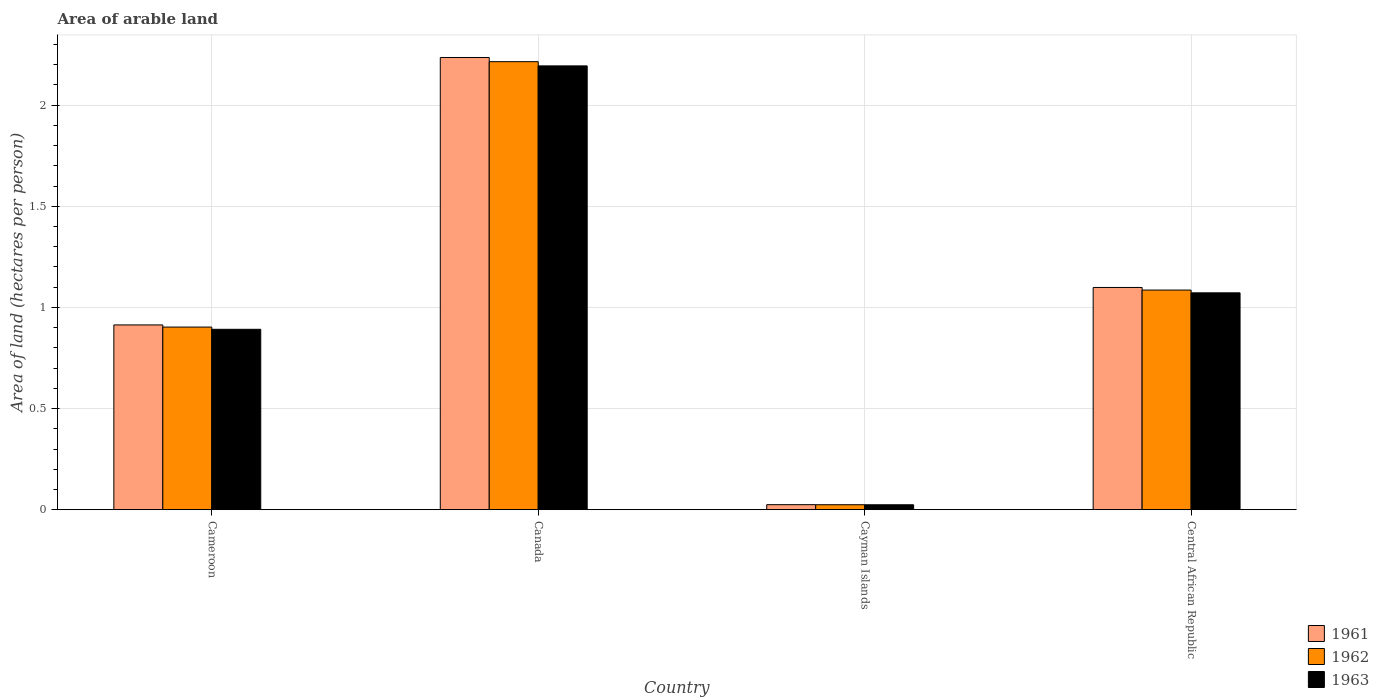How many different coloured bars are there?
Make the answer very short. 3. How many groups of bars are there?
Give a very brief answer. 4. Are the number of bars per tick equal to the number of legend labels?
Make the answer very short. Yes. How many bars are there on the 2nd tick from the left?
Your answer should be compact. 3. What is the label of the 4th group of bars from the left?
Make the answer very short. Central African Republic. What is the total arable land in 1962 in Central African Republic?
Your response must be concise. 1.09. Across all countries, what is the maximum total arable land in 1961?
Make the answer very short. 2.24. Across all countries, what is the minimum total arable land in 1963?
Offer a very short reply. 0.02. In which country was the total arable land in 1962 minimum?
Provide a succinct answer. Cayman Islands. What is the total total arable land in 1962 in the graph?
Keep it short and to the point. 4.23. What is the difference between the total arable land in 1962 in Cameroon and that in Cayman Islands?
Make the answer very short. 0.88. What is the difference between the total arable land in 1963 in Cayman Islands and the total arable land in 1961 in Central African Republic?
Provide a short and direct response. -1.07. What is the average total arable land in 1961 per country?
Offer a very short reply. 1.07. What is the difference between the total arable land of/in 1961 and total arable land of/in 1962 in Cayman Islands?
Keep it short and to the point. 0. In how many countries, is the total arable land in 1961 greater than 1.2 hectares per person?
Provide a succinct answer. 1. What is the ratio of the total arable land in 1963 in Cameroon to that in Cayman Islands?
Offer a terse response. 36.69. Is the difference between the total arable land in 1961 in Canada and Central African Republic greater than the difference between the total arable land in 1962 in Canada and Central African Republic?
Your answer should be very brief. Yes. What is the difference between the highest and the second highest total arable land in 1961?
Keep it short and to the point. -0.19. What is the difference between the highest and the lowest total arable land in 1961?
Your response must be concise. 2.21. In how many countries, is the total arable land in 1962 greater than the average total arable land in 1962 taken over all countries?
Your response must be concise. 2. Is the sum of the total arable land in 1961 in Cayman Islands and Central African Republic greater than the maximum total arable land in 1962 across all countries?
Your answer should be very brief. No. How many bars are there?
Ensure brevity in your answer.  12. Are all the bars in the graph horizontal?
Your response must be concise. No. How many countries are there in the graph?
Your answer should be very brief. 4. What is the difference between two consecutive major ticks on the Y-axis?
Your answer should be compact. 0.5. Does the graph contain any zero values?
Your answer should be very brief. No. Does the graph contain grids?
Give a very brief answer. Yes. How many legend labels are there?
Provide a succinct answer. 3. What is the title of the graph?
Keep it short and to the point. Area of arable land. Does "2004" appear as one of the legend labels in the graph?
Your response must be concise. No. What is the label or title of the Y-axis?
Your response must be concise. Area of land (hectares per person). What is the Area of land (hectares per person) of 1961 in Cameroon?
Your response must be concise. 0.91. What is the Area of land (hectares per person) of 1962 in Cameroon?
Make the answer very short. 0.9. What is the Area of land (hectares per person) of 1963 in Cameroon?
Your answer should be compact. 0.89. What is the Area of land (hectares per person) of 1961 in Canada?
Provide a succinct answer. 2.24. What is the Area of land (hectares per person) in 1962 in Canada?
Provide a short and direct response. 2.21. What is the Area of land (hectares per person) in 1963 in Canada?
Offer a very short reply. 2.19. What is the Area of land (hectares per person) in 1961 in Cayman Islands?
Keep it short and to the point. 0.02. What is the Area of land (hectares per person) of 1962 in Cayman Islands?
Your response must be concise. 0.02. What is the Area of land (hectares per person) in 1963 in Cayman Islands?
Your answer should be compact. 0.02. What is the Area of land (hectares per person) of 1961 in Central African Republic?
Ensure brevity in your answer.  1.1. What is the Area of land (hectares per person) in 1962 in Central African Republic?
Your answer should be very brief. 1.09. What is the Area of land (hectares per person) in 1963 in Central African Republic?
Make the answer very short. 1.07. Across all countries, what is the maximum Area of land (hectares per person) of 1961?
Your response must be concise. 2.24. Across all countries, what is the maximum Area of land (hectares per person) in 1962?
Your answer should be compact. 2.21. Across all countries, what is the maximum Area of land (hectares per person) of 1963?
Ensure brevity in your answer.  2.19. Across all countries, what is the minimum Area of land (hectares per person) in 1961?
Give a very brief answer. 0.02. Across all countries, what is the minimum Area of land (hectares per person) of 1962?
Your answer should be very brief. 0.02. Across all countries, what is the minimum Area of land (hectares per person) of 1963?
Provide a succinct answer. 0.02. What is the total Area of land (hectares per person) in 1961 in the graph?
Your answer should be compact. 4.27. What is the total Area of land (hectares per person) in 1962 in the graph?
Keep it short and to the point. 4.23. What is the total Area of land (hectares per person) of 1963 in the graph?
Offer a very short reply. 4.18. What is the difference between the Area of land (hectares per person) in 1961 in Cameroon and that in Canada?
Make the answer very short. -1.32. What is the difference between the Area of land (hectares per person) in 1962 in Cameroon and that in Canada?
Keep it short and to the point. -1.31. What is the difference between the Area of land (hectares per person) of 1963 in Cameroon and that in Canada?
Your answer should be very brief. -1.3. What is the difference between the Area of land (hectares per person) of 1961 in Cameroon and that in Cayman Islands?
Make the answer very short. 0.89. What is the difference between the Area of land (hectares per person) in 1962 in Cameroon and that in Cayman Islands?
Provide a short and direct response. 0.88. What is the difference between the Area of land (hectares per person) in 1963 in Cameroon and that in Cayman Islands?
Make the answer very short. 0.87. What is the difference between the Area of land (hectares per person) of 1961 in Cameroon and that in Central African Republic?
Ensure brevity in your answer.  -0.19. What is the difference between the Area of land (hectares per person) of 1962 in Cameroon and that in Central African Republic?
Make the answer very short. -0.18. What is the difference between the Area of land (hectares per person) of 1963 in Cameroon and that in Central African Republic?
Your response must be concise. -0.18. What is the difference between the Area of land (hectares per person) of 1961 in Canada and that in Cayman Islands?
Provide a succinct answer. 2.21. What is the difference between the Area of land (hectares per person) in 1962 in Canada and that in Cayman Islands?
Your answer should be compact. 2.19. What is the difference between the Area of land (hectares per person) in 1963 in Canada and that in Cayman Islands?
Offer a terse response. 2.17. What is the difference between the Area of land (hectares per person) in 1961 in Canada and that in Central African Republic?
Offer a very short reply. 1.14. What is the difference between the Area of land (hectares per person) in 1962 in Canada and that in Central African Republic?
Make the answer very short. 1.13. What is the difference between the Area of land (hectares per person) of 1963 in Canada and that in Central African Republic?
Provide a succinct answer. 1.12. What is the difference between the Area of land (hectares per person) of 1961 in Cayman Islands and that in Central African Republic?
Your response must be concise. -1.07. What is the difference between the Area of land (hectares per person) of 1962 in Cayman Islands and that in Central African Republic?
Make the answer very short. -1.06. What is the difference between the Area of land (hectares per person) of 1963 in Cayman Islands and that in Central African Republic?
Make the answer very short. -1.05. What is the difference between the Area of land (hectares per person) in 1961 in Cameroon and the Area of land (hectares per person) in 1962 in Canada?
Your answer should be compact. -1.3. What is the difference between the Area of land (hectares per person) in 1961 in Cameroon and the Area of land (hectares per person) in 1963 in Canada?
Ensure brevity in your answer.  -1.28. What is the difference between the Area of land (hectares per person) of 1962 in Cameroon and the Area of land (hectares per person) of 1963 in Canada?
Keep it short and to the point. -1.29. What is the difference between the Area of land (hectares per person) in 1961 in Cameroon and the Area of land (hectares per person) in 1962 in Cayman Islands?
Ensure brevity in your answer.  0.89. What is the difference between the Area of land (hectares per person) of 1961 in Cameroon and the Area of land (hectares per person) of 1963 in Cayman Islands?
Offer a very short reply. 0.89. What is the difference between the Area of land (hectares per person) in 1962 in Cameroon and the Area of land (hectares per person) in 1963 in Cayman Islands?
Make the answer very short. 0.88. What is the difference between the Area of land (hectares per person) of 1961 in Cameroon and the Area of land (hectares per person) of 1962 in Central African Republic?
Make the answer very short. -0.17. What is the difference between the Area of land (hectares per person) in 1961 in Cameroon and the Area of land (hectares per person) in 1963 in Central African Republic?
Make the answer very short. -0.16. What is the difference between the Area of land (hectares per person) in 1962 in Cameroon and the Area of land (hectares per person) in 1963 in Central African Republic?
Ensure brevity in your answer.  -0.17. What is the difference between the Area of land (hectares per person) in 1961 in Canada and the Area of land (hectares per person) in 1962 in Cayman Islands?
Provide a short and direct response. 2.21. What is the difference between the Area of land (hectares per person) of 1961 in Canada and the Area of land (hectares per person) of 1963 in Cayman Islands?
Your response must be concise. 2.21. What is the difference between the Area of land (hectares per person) in 1962 in Canada and the Area of land (hectares per person) in 1963 in Cayman Islands?
Give a very brief answer. 2.19. What is the difference between the Area of land (hectares per person) in 1961 in Canada and the Area of land (hectares per person) in 1962 in Central African Republic?
Your answer should be very brief. 1.15. What is the difference between the Area of land (hectares per person) in 1961 in Canada and the Area of land (hectares per person) in 1963 in Central African Republic?
Make the answer very short. 1.16. What is the difference between the Area of land (hectares per person) in 1962 in Canada and the Area of land (hectares per person) in 1963 in Central African Republic?
Provide a short and direct response. 1.14. What is the difference between the Area of land (hectares per person) of 1961 in Cayman Islands and the Area of land (hectares per person) of 1962 in Central African Republic?
Provide a short and direct response. -1.06. What is the difference between the Area of land (hectares per person) of 1961 in Cayman Islands and the Area of land (hectares per person) of 1963 in Central African Republic?
Give a very brief answer. -1.05. What is the difference between the Area of land (hectares per person) in 1962 in Cayman Islands and the Area of land (hectares per person) in 1963 in Central African Republic?
Offer a very short reply. -1.05. What is the average Area of land (hectares per person) of 1961 per country?
Ensure brevity in your answer.  1.07. What is the average Area of land (hectares per person) in 1962 per country?
Your response must be concise. 1.06. What is the average Area of land (hectares per person) of 1963 per country?
Make the answer very short. 1.05. What is the difference between the Area of land (hectares per person) of 1961 and Area of land (hectares per person) of 1962 in Cameroon?
Provide a short and direct response. 0.01. What is the difference between the Area of land (hectares per person) in 1961 and Area of land (hectares per person) in 1963 in Cameroon?
Your answer should be compact. 0.02. What is the difference between the Area of land (hectares per person) of 1962 and Area of land (hectares per person) of 1963 in Cameroon?
Your answer should be compact. 0.01. What is the difference between the Area of land (hectares per person) in 1961 and Area of land (hectares per person) in 1962 in Canada?
Offer a very short reply. 0.02. What is the difference between the Area of land (hectares per person) of 1961 and Area of land (hectares per person) of 1963 in Canada?
Provide a succinct answer. 0.04. What is the difference between the Area of land (hectares per person) of 1962 and Area of land (hectares per person) of 1963 in Canada?
Offer a terse response. 0.02. What is the difference between the Area of land (hectares per person) in 1961 and Area of land (hectares per person) in 1963 in Cayman Islands?
Provide a short and direct response. 0. What is the difference between the Area of land (hectares per person) in 1961 and Area of land (hectares per person) in 1962 in Central African Republic?
Keep it short and to the point. 0.01. What is the difference between the Area of land (hectares per person) in 1961 and Area of land (hectares per person) in 1963 in Central African Republic?
Ensure brevity in your answer.  0.03. What is the difference between the Area of land (hectares per person) of 1962 and Area of land (hectares per person) of 1963 in Central African Republic?
Your answer should be very brief. 0.01. What is the ratio of the Area of land (hectares per person) in 1961 in Cameroon to that in Canada?
Keep it short and to the point. 0.41. What is the ratio of the Area of land (hectares per person) of 1962 in Cameroon to that in Canada?
Your response must be concise. 0.41. What is the ratio of the Area of land (hectares per person) in 1963 in Cameroon to that in Canada?
Your response must be concise. 0.41. What is the ratio of the Area of land (hectares per person) of 1961 in Cameroon to that in Cayman Islands?
Keep it short and to the point. 36.65. What is the ratio of the Area of land (hectares per person) of 1962 in Cameroon to that in Cayman Islands?
Keep it short and to the point. 36.75. What is the ratio of the Area of land (hectares per person) in 1963 in Cameroon to that in Cayman Islands?
Your response must be concise. 36.69. What is the ratio of the Area of land (hectares per person) in 1961 in Cameroon to that in Central African Republic?
Make the answer very short. 0.83. What is the ratio of the Area of land (hectares per person) of 1962 in Cameroon to that in Central African Republic?
Offer a very short reply. 0.83. What is the ratio of the Area of land (hectares per person) in 1963 in Cameroon to that in Central African Republic?
Your answer should be compact. 0.83. What is the ratio of the Area of land (hectares per person) in 1961 in Canada to that in Cayman Islands?
Make the answer very short. 89.71. What is the ratio of the Area of land (hectares per person) of 1962 in Canada to that in Cayman Islands?
Keep it short and to the point. 90.16. What is the ratio of the Area of land (hectares per person) of 1963 in Canada to that in Cayman Islands?
Your answer should be compact. 90.25. What is the ratio of the Area of land (hectares per person) of 1961 in Canada to that in Central African Republic?
Offer a very short reply. 2.03. What is the ratio of the Area of land (hectares per person) of 1962 in Canada to that in Central African Republic?
Make the answer very short. 2.04. What is the ratio of the Area of land (hectares per person) of 1963 in Canada to that in Central African Republic?
Provide a short and direct response. 2.05. What is the ratio of the Area of land (hectares per person) in 1961 in Cayman Islands to that in Central African Republic?
Your answer should be compact. 0.02. What is the ratio of the Area of land (hectares per person) in 1962 in Cayman Islands to that in Central African Republic?
Provide a succinct answer. 0.02. What is the ratio of the Area of land (hectares per person) in 1963 in Cayman Islands to that in Central African Republic?
Provide a succinct answer. 0.02. What is the difference between the highest and the second highest Area of land (hectares per person) in 1961?
Keep it short and to the point. 1.14. What is the difference between the highest and the second highest Area of land (hectares per person) of 1962?
Keep it short and to the point. 1.13. What is the difference between the highest and the second highest Area of land (hectares per person) in 1963?
Provide a short and direct response. 1.12. What is the difference between the highest and the lowest Area of land (hectares per person) of 1961?
Your response must be concise. 2.21. What is the difference between the highest and the lowest Area of land (hectares per person) of 1962?
Provide a short and direct response. 2.19. What is the difference between the highest and the lowest Area of land (hectares per person) of 1963?
Give a very brief answer. 2.17. 